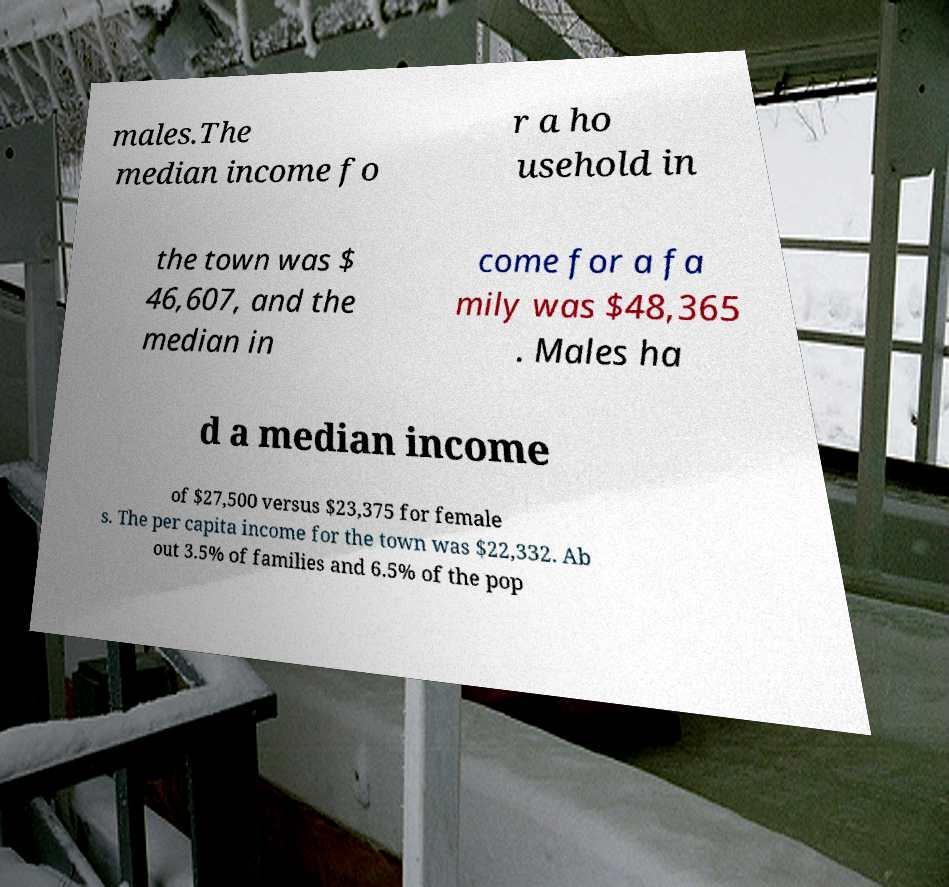Could you assist in decoding the text presented in this image and type it out clearly? males.The median income fo r a ho usehold in the town was $ 46,607, and the median in come for a fa mily was $48,365 . Males ha d a median income of $27,500 versus $23,375 for female s. The per capita income for the town was $22,332. Ab out 3.5% of families and 6.5% of the pop 